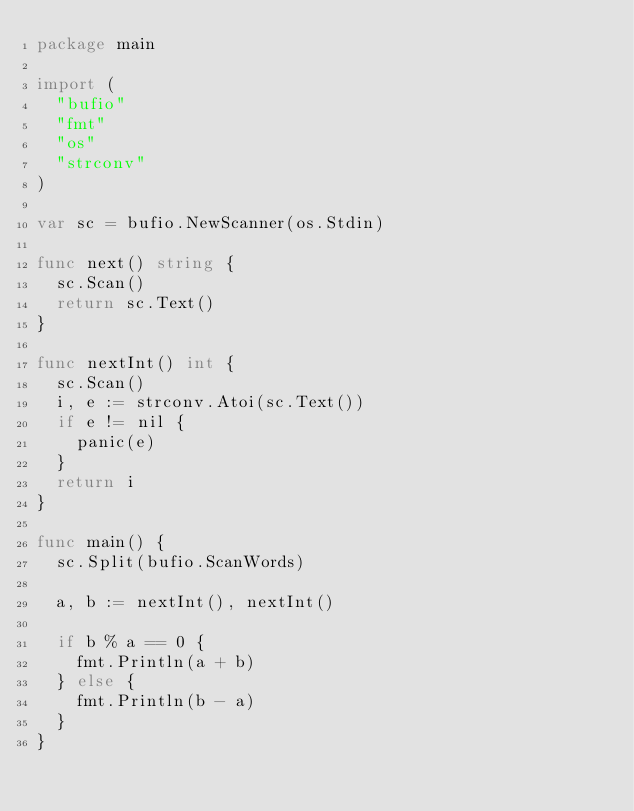Convert code to text. <code><loc_0><loc_0><loc_500><loc_500><_Go_>package main

import (
	"bufio"
	"fmt"
	"os"
	"strconv"
)

var sc = bufio.NewScanner(os.Stdin)

func next() string {
	sc.Scan()
	return sc.Text()
}

func nextInt() int {
	sc.Scan()
	i, e := strconv.Atoi(sc.Text())
	if e != nil {
		panic(e)
	}
	return i
}

func main() {
	sc.Split(bufio.ScanWords)

	a, b := nextInt(), nextInt()

	if b % a == 0 {
		fmt.Println(a + b)
	} else {
		fmt.Println(b - a)
	}
}</code> 